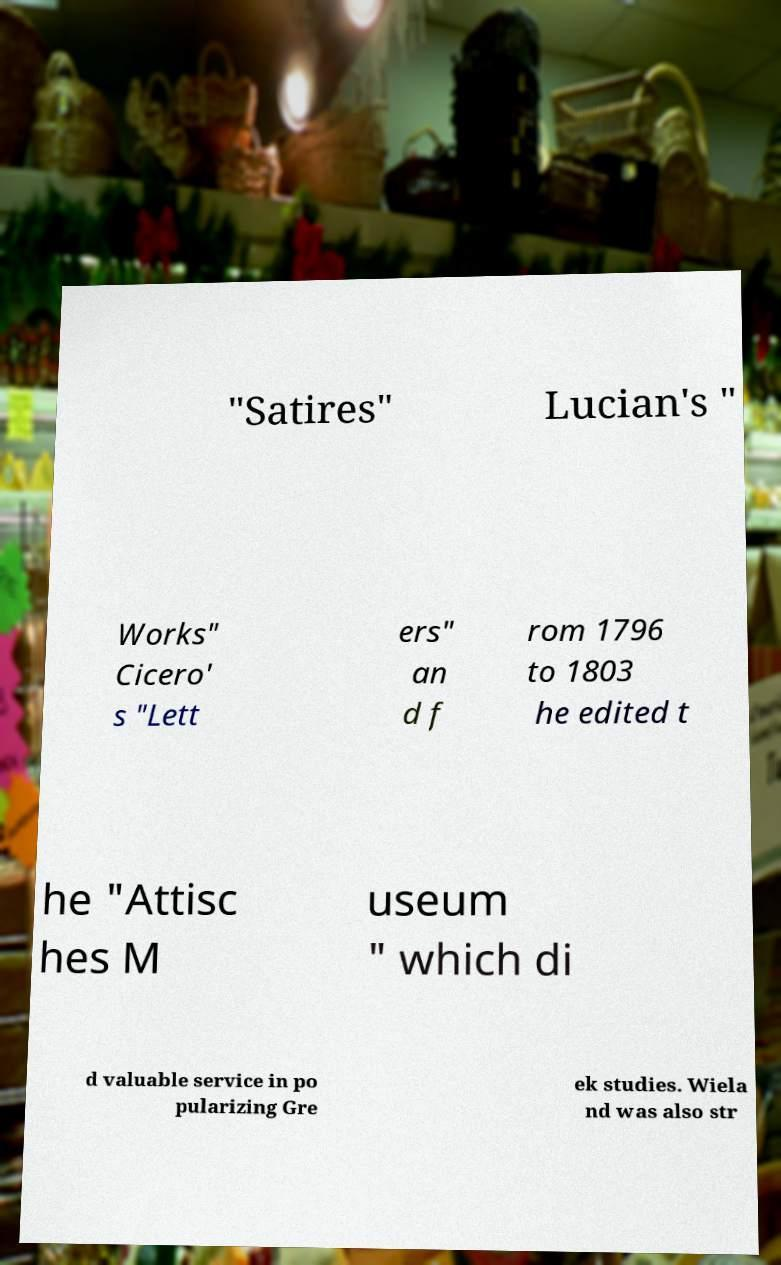For documentation purposes, I need the text within this image transcribed. Could you provide that? "Satires" Lucian's " Works" Cicero' s "Lett ers" an d f rom 1796 to 1803 he edited t he "Attisc hes M useum " which di d valuable service in po pularizing Gre ek studies. Wiela nd was also str 